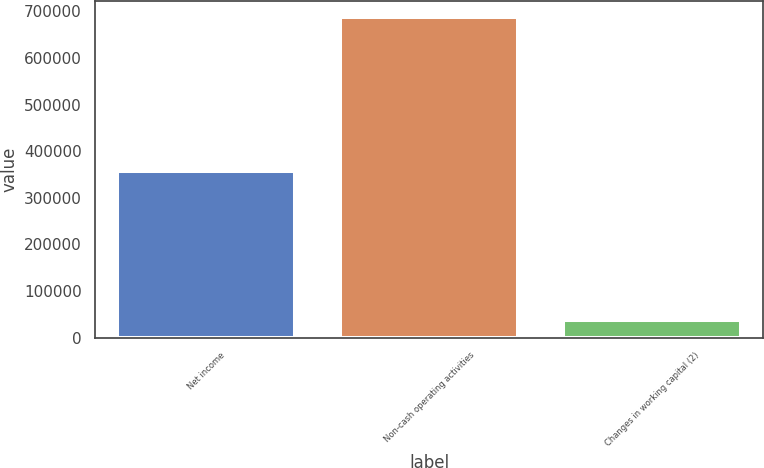Convert chart. <chart><loc_0><loc_0><loc_500><loc_500><bar_chart><fcel>Net income<fcel>Non-cash operating activities<fcel>Changes in working capital (2)<nl><fcel>358070<fcel>688126<fcel>38812<nl></chart> 